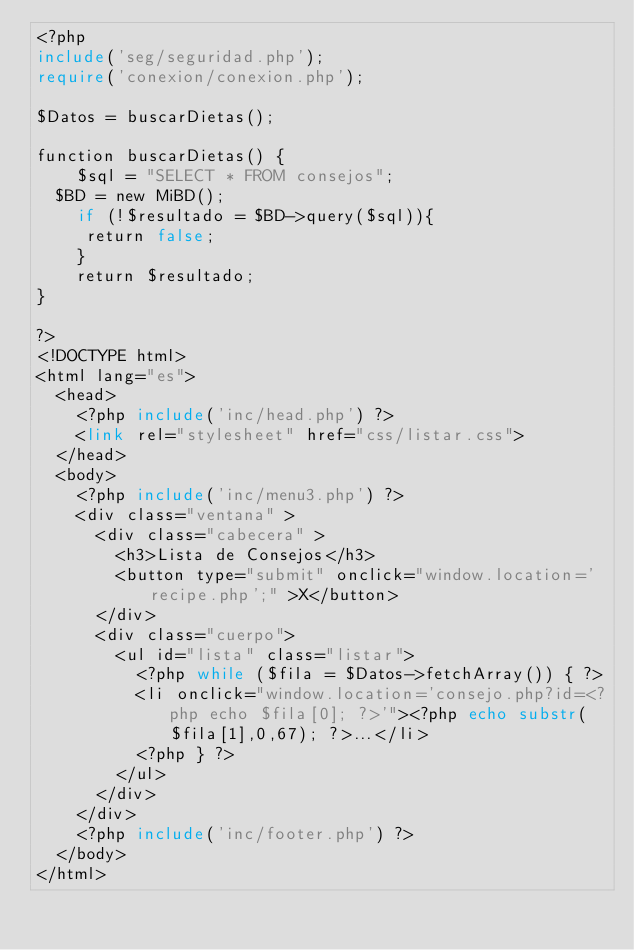<code> <loc_0><loc_0><loc_500><loc_500><_PHP_><?php 
include('seg/seguridad.php');
require('conexion/conexion.php');

$Datos = buscarDietas();

function buscarDietas() {
    $sql = "SELECT * FROM consejos";
	$BD = new MiBD();
    if (!$resultado = $BD->query($sql)){
	   return false;
    }
    return $resultado;    
}

?>
<!DOCTYPE html>
<html lang="es">
	<head>
		<?php include('inc/head.php') ?>
		<link rel="stylesheet" href="css/listar.css">
	</head>
	<body>
		<?php include('inc/menu3.php') ?>
		<div class="ventana" >
			<div class="cabecera" >
				<h3>Lista de Consejos</h3>
				<button type="submit" onclick="window.location='recipe.php';" >X</button>	
			</div>
			<div class="cuerpo">
				<ul id="lista" class="listar">
					<?php while ($fila = $Datos->fetchArray()) { ?>
					<li onclick="window.location='consejo.php?id=<?php echo $fila[0]; ?>'"><?php echo substr($fila[1],0,67); ?>...</li>
					<?php } ?>
				</ul>
			</div>
		</div>
		<?php include('inc/footer.php') ?>
	</body>
</html></code> 